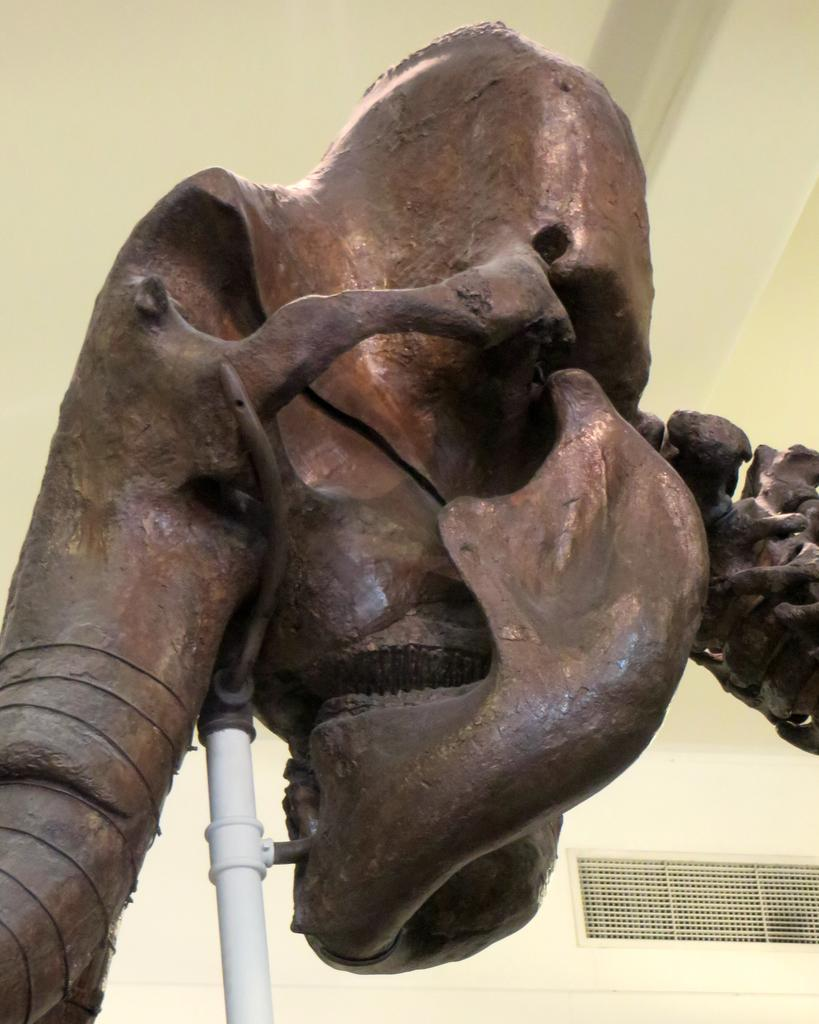What is the main subject of the image? The main subject of the image is a sculpture. What material is used for the metal rod in the image? The metal rod in the image is made of metal. What type of observation can be made about the cook in the image? There is no cook present in the image. What is the size of the hall in the image? There is no hall present in the image. 